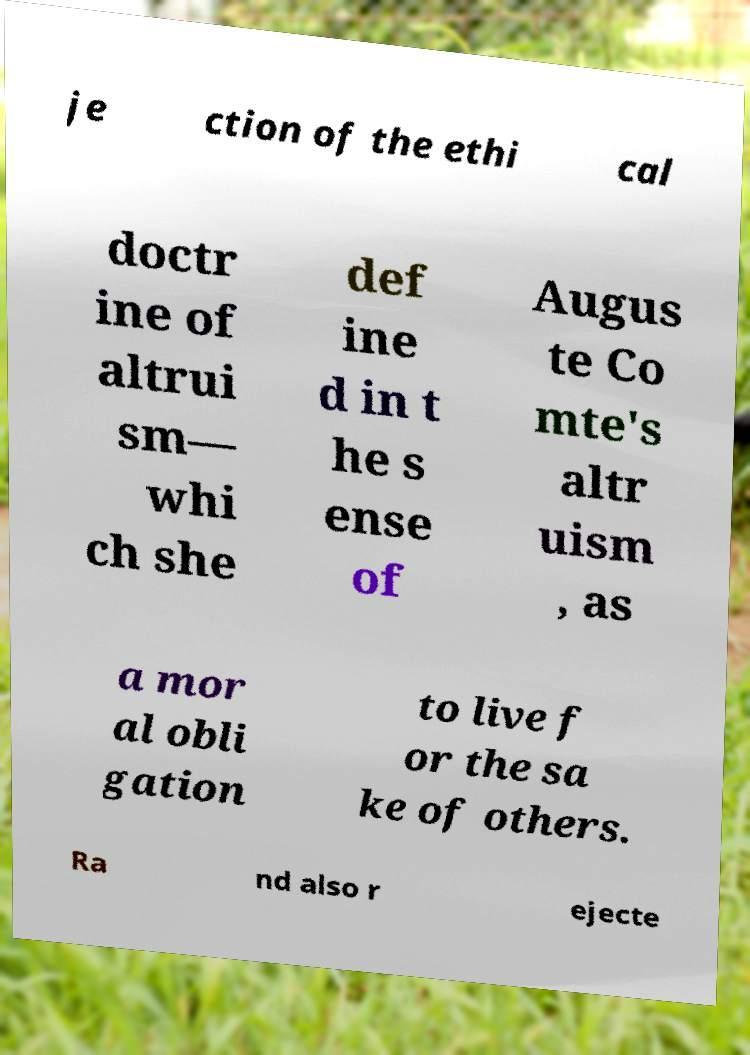Can you accurately transcribe the text from the provided image for me? je ction of the ethi cal doctr ine of altrui sm— whi ch she def ine d in t he s ense of Augus te Co mte's altr uism , as a mor al obli gation to live f or the sa ke of others. Ra nd also r ejecte 